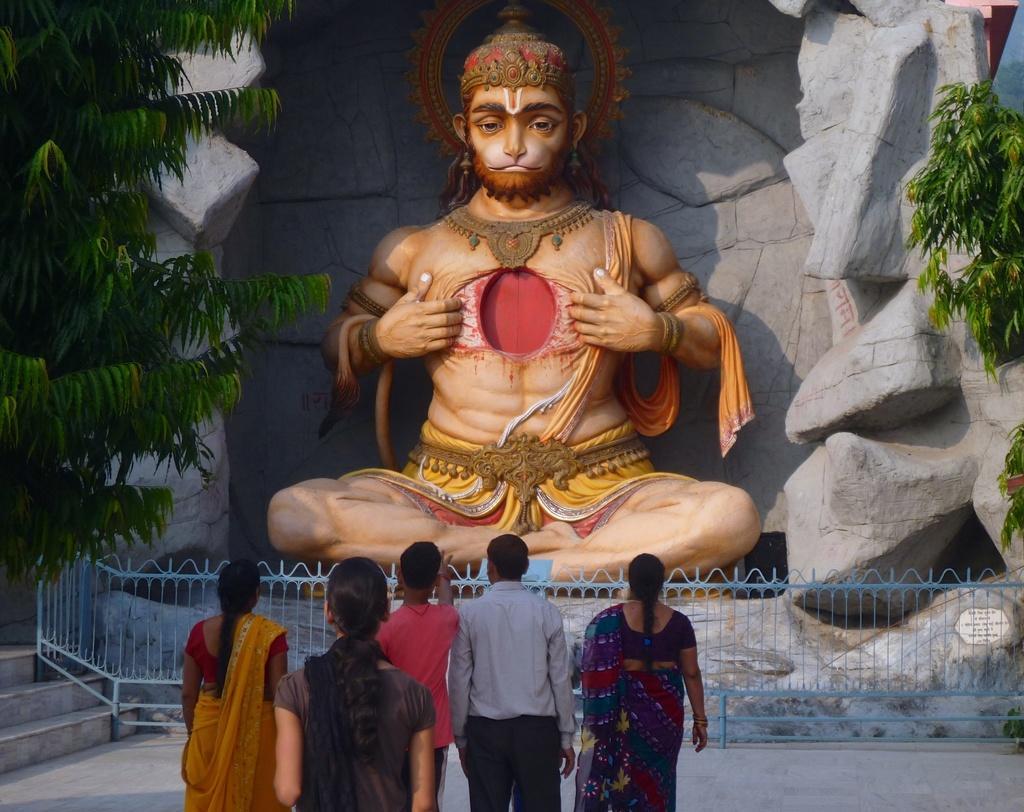In one or two sentences, can you explain what this image depicts? In this image we can see a statue. There are few people. Also there is a railing. There are steps and trees. In the background there is a wall with rocks. 